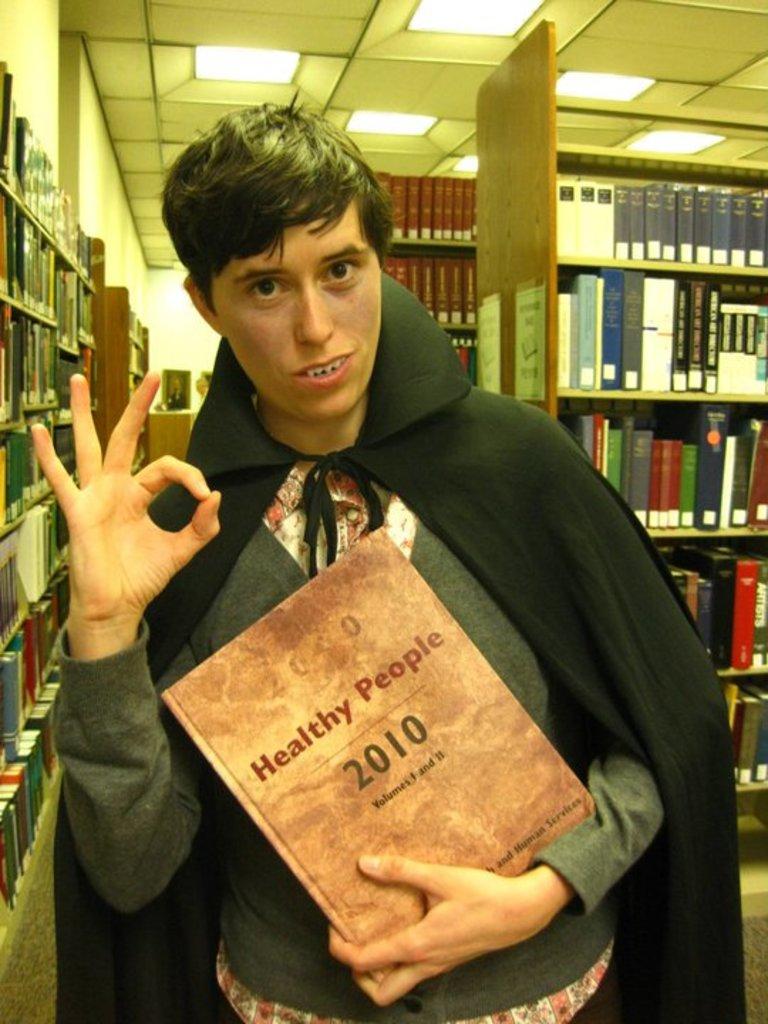What year is the book?
Your response must be concise. 2010. 